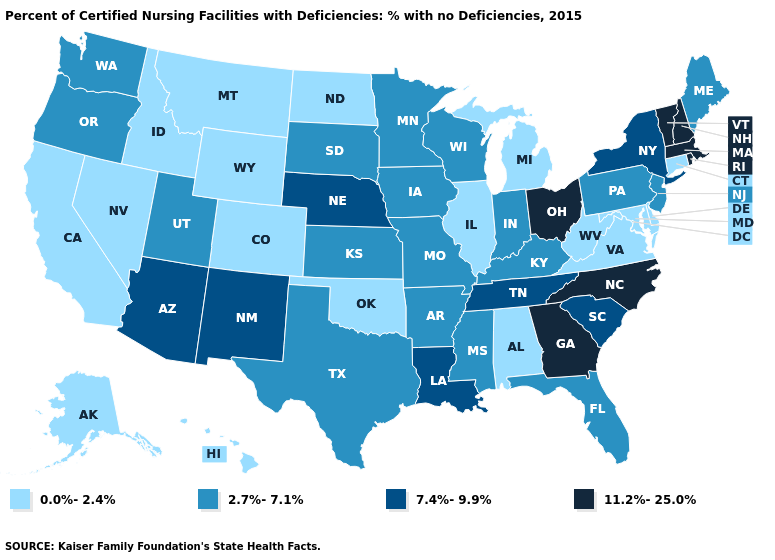Name the states that have a value in the range 11.2%-25.0%?
Keep it brief. Georgia, Massachusetts, New Hampshire, North Carolina, Ohio, Rhode Island, Vermont. Name the states that have a value in the range 0.0%-2.4%?
Give a very brief answer. Alabama, Alaska, California, Colorado, Connecticut, Delaware, Hawaii, Idaho, Illinois, Maryland, Michigan, Montana, Nevada, North Dakota, Oklahoma, Virginia, West Virginia, Wyoming. Does the first symbol in the legend represent the smallest category?
Give a very brief answer. Yes. What is the highest value in states that border Texas?
Short answer required. 7.4%-9.9%. Among the states that border North Dakota , which have the lowest value?
Give a very brief answer. Montana. Name the states that have a value in the range 7.4%-9.9%?
Answer briefly. Arizona, Louisiana, Nebraska, New Mexico, New York, South Carolina, Tennessee. Which states have the lowest value in the USA?
Short answer required. Alabama, Alaska, California, Colorado, Connecticut, Delaware, Hawaii, Idaho, Illinois, Maryland, Michigan, Montana, Nevada, North Dakota, Oklahoma, Virginia, West Virginia, Wyoming. Is the legend a continuous bar?
Quick response, please. No. What is the highest value in states that border Illinois?
Answer briefly. 2.7%-7.1%. What is the value of North Dakota?
Short answer required. 0.0%-2.4%. Name the states that have a value in the range 2.7%-7.1%?
Answer briefly. Arkansas, Florida, Indiana, Iowa, Kansas, Kentucky, Maine, Minnesota, Mississippi, Missouri, New Jersey, Oregon, Pennsylvania, South Dakota, Texas, Utah, Washington, Wisconsin. Does New Jersey have the highest value in the USA?
Be succinct. No. Does the first symbol in the legend represent the smallest category?
Answer briefly. Yes. Does West Virginia have the lowest value in the South?
Give a very brief answer. Yes. What is the value of Pennsylvania?
Quick response, please. 2.7%-7.1%. 